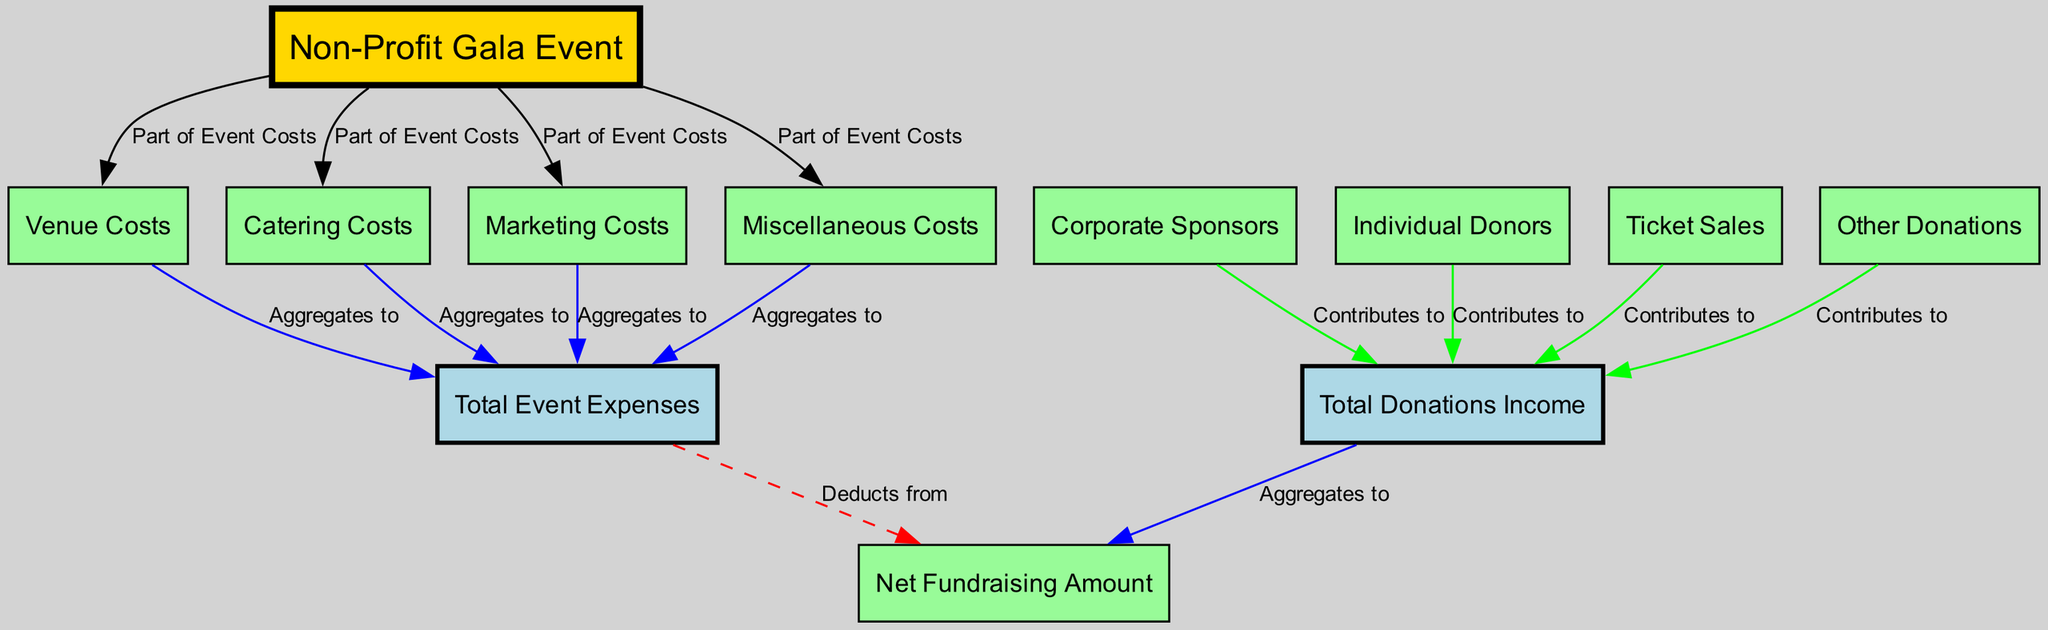what is the total number of nodes in the diagram? The diagram contains a defined set of nodes that represent different entities and categories within the Non-Profit Gala Event. Counting each unique node listed in the provided data, we find there are twelve nodes in total.
Answer: 12 what is one source of total event expenses? The total event expenses are aggregated from various sources. Among the listed sources, 'venue costs' is one straightforward example contributing to the total event expenses.
Answer: Venue Costs how many sources contribute to total donations income? The diagram lists four distinct sources that contribute to the total donations income. They are corporate sponsors, individual donors, ticket sales, and other donations.
Answer: 4 which node deducts from net fundraising amount? In the diagram flow, the total event expenses are indicated as the node that deducts from the net fundraising amount, implying that it reduces the fundraising total.
Answer: Total Event Expenses what is the relationship between ticket sales and total donations income? The diagram illustrates that the ticket sales contribute to the total donations income, indicating a positive flow of funds from the ticket sales node to the income node.
Answer: Contributes to which type of costs are represented as 'lightcoral' in the diagram? The color coding in the diagram designates that costs related to the event, specifically venue costs, catering costs, marketing costs, and miscellaneous costs, are all represented in 'lightcoral.'
Answer: Catering Costs how do corporate sponsors influence the overall fundraising outcome? The corporate sponsors contribute a portion to the total donations income, which in turn aggregates to the net fundraising amount. Their contributions directly enhance the overall available funds.
Answer: Contributes to how is net fundraising amount calculated from other nodes? The net fundraising amount is derived by aggregating total income from various sources (such as donations, ticket sales) and then subtracting the total expenses associated with the event. This demonstrates a clear flow of funds affecting the net outcome.
Answer: Total Income and Total Event Expenses 